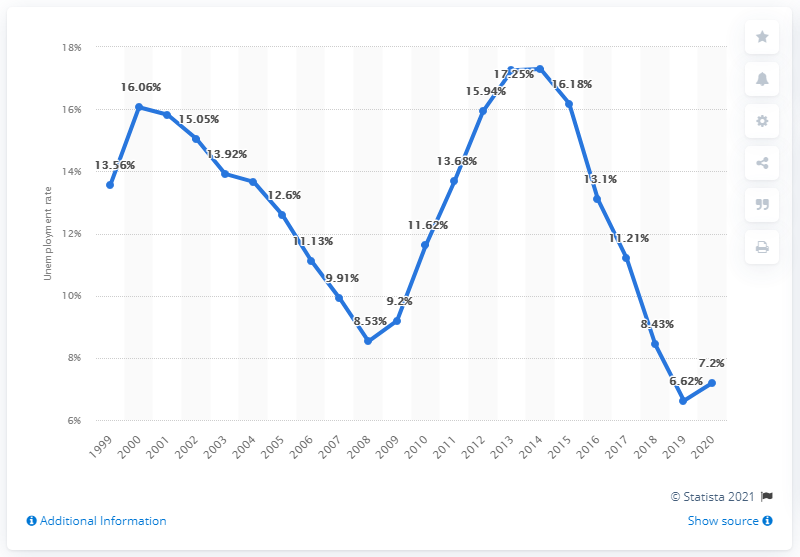Indicate a few pertinent items in this graphic. According to data from 2020, the unemployment rate in Croatia was 7.2%. 